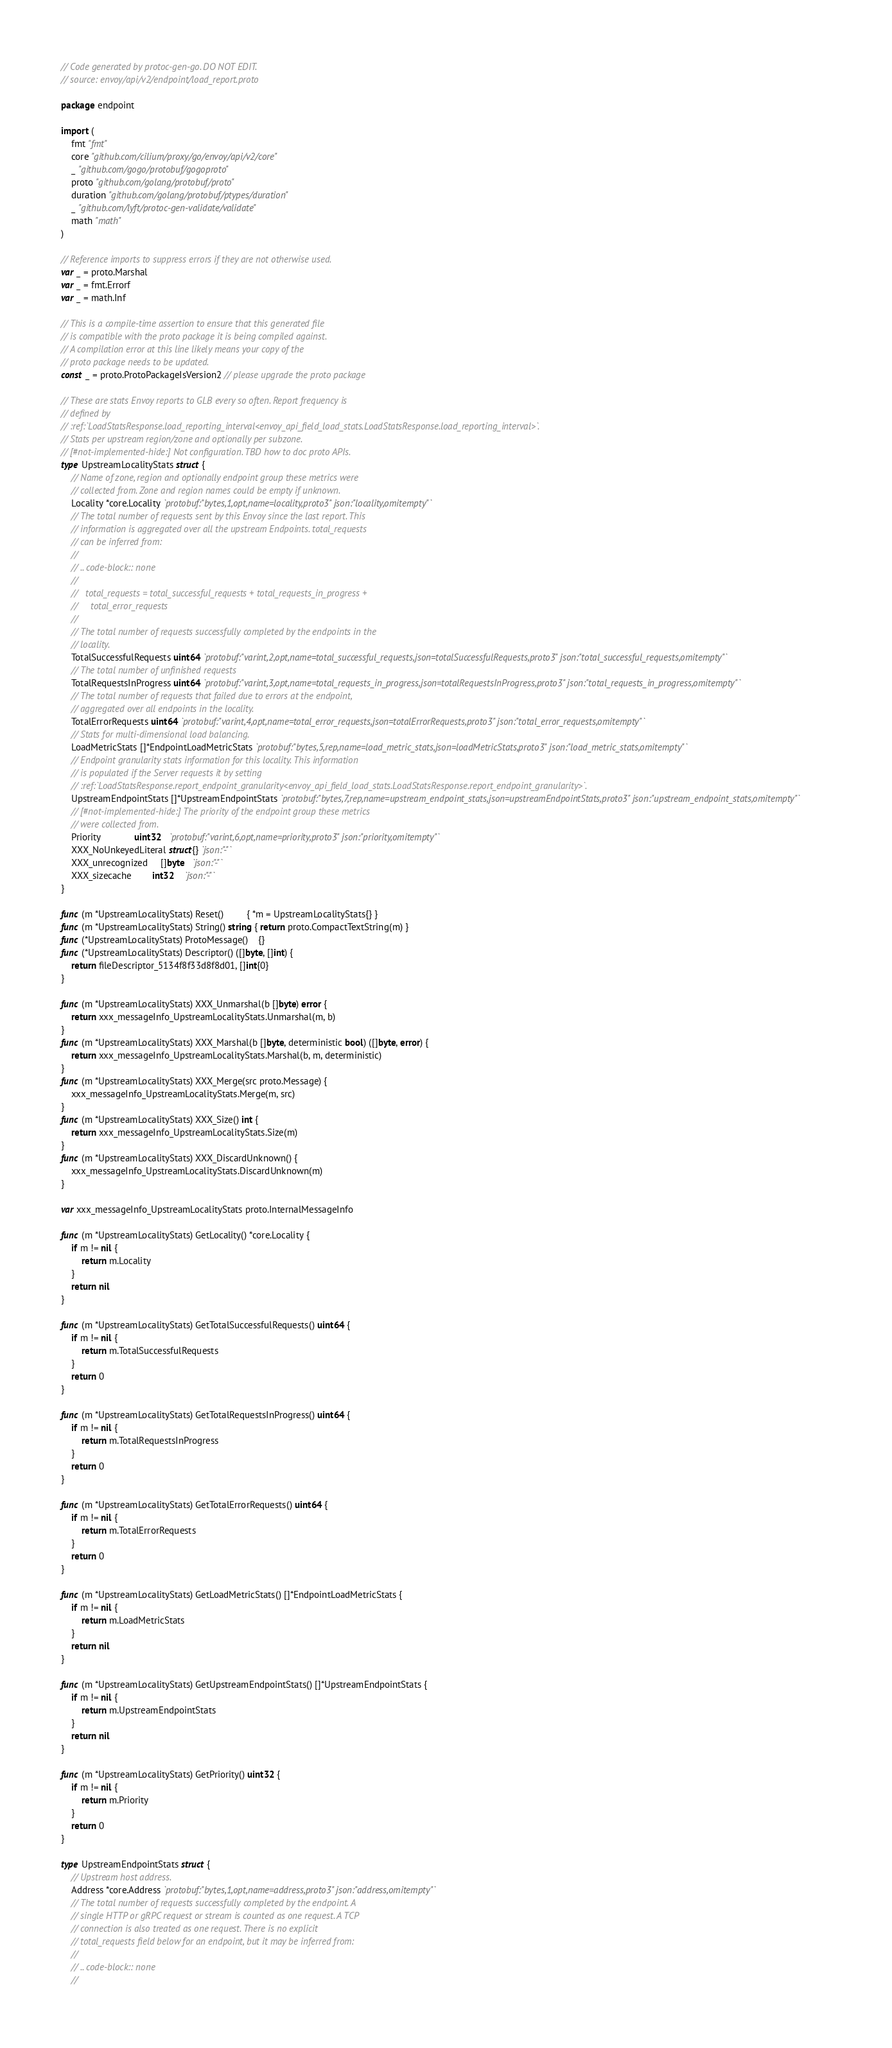Convert code to text. <code><loc_0><loc_0><loc_500><loc_500><_Go_>// Code generated by protoc-gen-go. DO NOT EDIT.
// source: envoy/api/v2/endpoint/load_report.proto

package endpoint

import (
	fmt "fmt"
	core "github.com/cilium/proxy/go/envoy/api/v2/core"
	_ "github.com/gogo/protobuf/gogoproto"
	proto "github.com/golang/protobuf/proto"
	duration "github.com/golang/protobuf/ptypes/duration"
	_ "github.com/lyft/protoc-gen-validate/validate"
	math "math"
)

// Reference imports to suppress errors if they are not otherwise used.
var _ = proto.Marshal
var _ = fmt.Errorf
var _ = math.Inf

// This is a compile-time assertion to ensure that this generated file
// is compatible with the proto package it is being compiled against.
// A compilation error at this line likely means your copy of the
// proto package needs to be updated.
const _ = proto.ProtoPackageIsVersion2 // please upgrade the proto package

// These are stats Envoy reports to GLB every so often. Report frequency is
// defined by
// :ref:`LoadStatsResponse.load_reporting_interval<envoy_api_field_load_stats.LoadStatsResponse.load_reporting_interval>`.
// Stats per upstream region/zone and optionally per subzone.
// [#not-implemented-hide:] Not configuration. TBD how to doc proto APIs.
type UpstreamLocalityStats struct {
	// Name of zone, region and optionally endpoint group these metrics were
	// collected from. Zone and region names could be empty if unknown.
	Locality *core.Locality `protobuf:"bytes,1,opt,name=locality,proto3" json:"locality,omitempty"`
	// The total number of requests sent by this Envoy since the last report. This
	// information is aggregated over all the upstream Endpoints. total_requests
	// can be inferred from:
	//
	// .. code-block:: none
	//
	//   total_requests = total_successful_requests + total_requests_in_progress +
	//     total_error_requests
	//
	// The total number of requests successfully completed by the endpoints in the
	// locality.
	TotalSuccessfulRequests uint64 `protobuf:"varint,2,opt,name=total_successful_requests,json=totalSuccessfulRequests,proto3" json:"total_successful_requests,omitempty"`
	// The total number of unfinished requests
	TotalRequestsInProgress uint64 `protobuf:"varint,3,opt,name=total_requests_in_progress,json=totalRequestsInProgress,proto3" json:"total_requests_in_progress,omitempty"`
	// The total number of requests that failed due to errors at the endpoint,
	// aggregated over all endpoints in the locality.
	TotalErrorRequests uint64 `protobuf:"varint,4,opt,name=total_error_requests,json=totalErrorRequests,proto3" json:"total_error_requests,omitempty"`
	// Stats for multi-dimensional load balancing.
	LoadMetricStats []*EndpointLoadMetricStats `protobuf:"bytes,5,rep,name=load_metric_stats,json=loadMetricStats,proto3" json:"load_metric_stats,omitempty"`
	// Endpoint granularity stats information for this locality. This information
	// is populated if the Server requests it by setting
	// :ref:`LoadStatsResponse.report_endpoint_granularity<envoy_api_field_load_stats.LoadStatsResponse.report_endpoint_granularity>`.
	UpstreamEndpointStats []*UpstreamEndpointStats `protobuf:"bytes,7,rep,name=upstream_endpoint_stats,json=upstreamEndpointStats,proto3" json:"upstream_endpoint_stats,omitempty"`
	// [#not-implemented-hide:] The priority of the endpoint group these metrics
	// were collected from.
	Priority             uint32   `protobuf:"varint,6,opt,name=priority,proto3" json:"priority,omitempty"`
	XXX_NoUnkeyedLiteral struct{} `json:"-"`
	XXX_unrecognized     []byte   `json:"-"`
	XXX_sizecache        int32    `json:"-"`
}

func (m *UpstreamLocalityStats) Reset()         { *m = UpstreamLocalityStats{} }
func (m *UpstreamLocalityStats) String() string { return proto.CompactTextString(m) }
func (*UpstreamLocalityStats) ProtoMessage()    {}
func (*UpstreamLocalityStats) Descriptor() ([]byte, []int) {
	return fileDescriptor_5134f8f33d8f8d01, []int{0}
}

func (m *UpstreamLocalityStats) XXX_Unmarshal(b []byte) error {
	return xxx_messageInfo_UpstreamLocalityStats.Unmarshal(m, b)
}
func (m *UpstreamLocalityStats) XXX_Marshal(b []byte, deterministic bool) ([]byte, error) {
	return xxx_messageInfo_UpstreamLocalityStats.Marshal(b, m, deterministic)
}
func (m *UpstreamLocalityStats) XXX_Merge(src proto.Message) {
	xxx_messageInfo_UpstreamLocalityStats.Merge(m, src)
}
func (m *UpstreamLocalityStats) XXX_Size() int {
	return xxx_messageInfo_UpstreamLocalityStats.Size(m)
}
func (m *UpstreamLocalityStats) XXX_DiscardUnknown() {
	xxx_messageInfo_UpstreamLocalityStats.DiscardUnknown(m)
}

var xxx_messageInfo_UpstreamLocalityStats proto.InternalMessageInfo

func (m *UpstreamLocalityStats) GetLocality() *core.Locality {
	if m != nil {
		return m.Locality
	}
	return nil
}

func (m *UpstreamLocalityStats) GetTotalSuccessfulRequests() uint64 {
	if m != nil {
		return m.TotalSuccessfulRequests
	}
	return 0
}

func (m *UpstreamLocalityStats) GetTotalRequestsInProgress() uint64 {
	if m != nil {
		return m.TotalRequestsInProgress
	}
	return 0
}

func (m *UpstreamLocalityStats) GetTotalErrorRequests() uint64 {
	if m != nil {
		return m.TotalErrorRequests
	}
	return 0
}

func (m *UpstreamLocalityStats) GetLoadMetricStats() []*EndpointLoadMetricStats {
	if m != nil {
		return m.LoadMetricStats
	}
	return nil
}

func (m *UpstreamLocalityStats) GetUpstreamEndpointStats() []*UpstreamEndpointStats {
	if m != nil {
		return m.UpstreamEndpointStats
	}
	return nil
}

func (m *UpstreamLocalityStats) GetPriority() uint32 {
	if m != nil {
		return m.Priority
	}
	return 0
}

type UpstreamEndpointStats struct {
	// Upstream host address.
	Address *core.Address `protobuf:"bytes,1,opt,name=address,proto3" json:"address,omitempty"`
	// The total number of requests successfully completed by the endpoint. A
	// single HTTP or gRPC request or stream is counted as one request. A TCP
	// connection is also treated as one request. There is no explicit
	// total_requests field below for an endpoint, but it may be inferred from:
	//
	// .. code-block:: none
	//</code> 